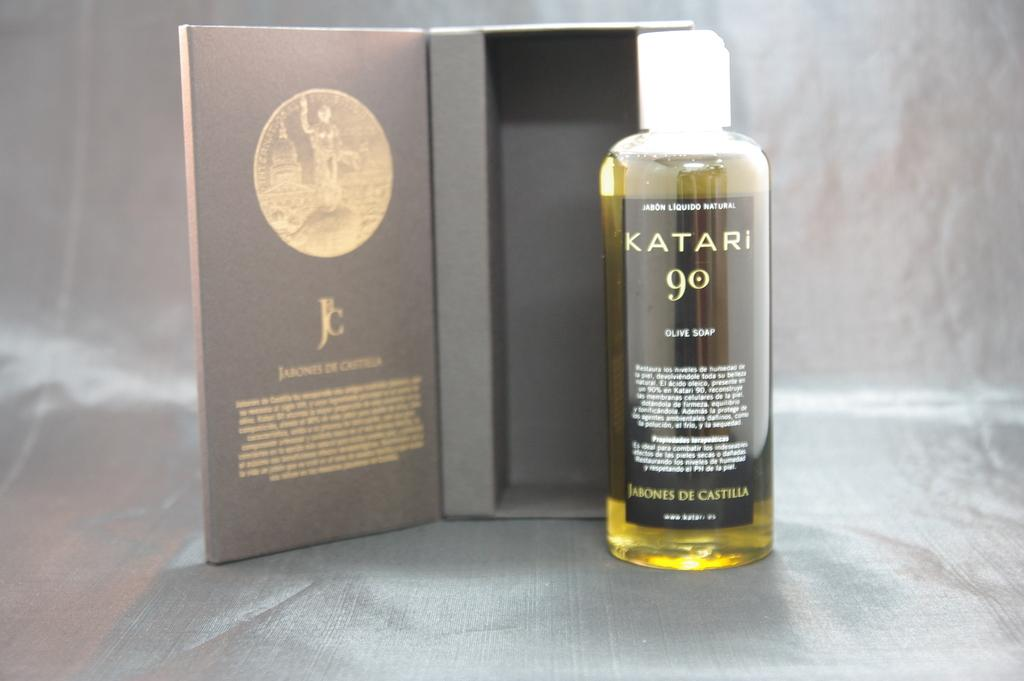<image>
Relay a brief, clear account of the picture shown. A bottle of Katari 9 olive soap sits outside of a box. 